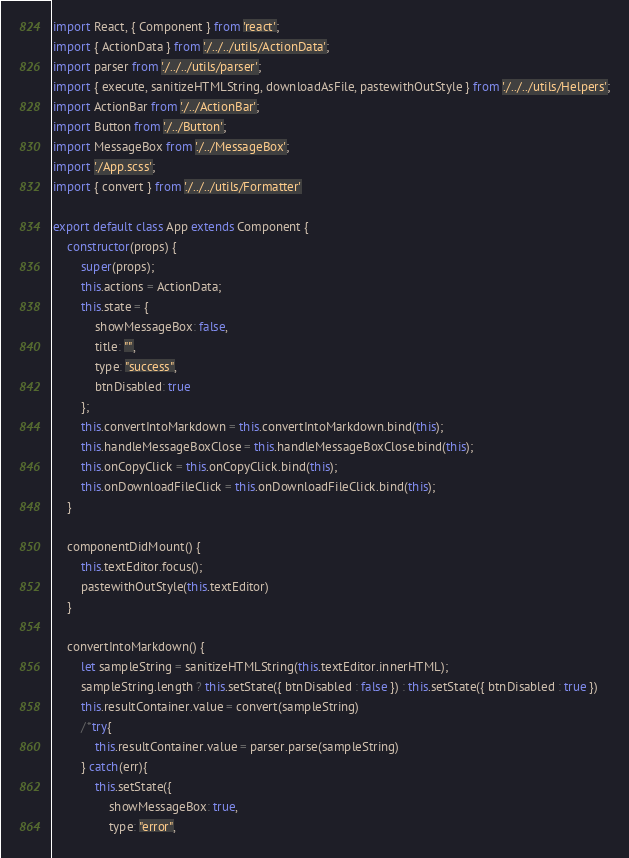<code> <loc_0><loc_0><loc_500><loc_500><_JavaScript_>import React, { Component } from 'react';
import { ActionData } from './../../utils/ActionData';
import parser from './../../utils/parser';
import { execute, sanitizeHTMLString, downloadAsFile, pastewithOutStyle } from './../../utils/Helpers';
import ActionBar from './../ActionBar';
import Button from './../Button';
import MessageBox from './../MessageBox';
import './App.scss';
import { convert } from './../../utils/Formatter'

export default class App extends Component {
    constructor(props) {
        super(props);
        this.actions = ActionData;
        this.state = {
            showMessageBox: false,
            title: "",
            type: "success",
            btnDisabled: true
        };
        this.convertIntoMarkdown = this.convertIntoMarkdown.bind(this);
        this.handleMessageBoxClose = this.handleMessageBoxClose.bind(this);
        this.onCopyClick = this.onCopyClick.bind(this);
        this.onDownloadFileClick = this.onDownloadFileClick.bind(this);
    }

    componentDidMount() {
        this.textEditor.focus();
        pastewithOutStyle(this.textEditor)
    }

    convertIntoMarkdown() {
        let sampleString = sanitizeHTMLString(this.textEditor.innerHTML);
        sampleString.length ? this.setState({ btnDisabled : false }) : this.setState({ btnDisabled : true })
        this.resultContainer.value = convert(sampleString)
        /*try{
            this.resultContainer.value = parser.parse(sampleString)
        } catch(err){   
            this.setState({
                showMessageBox: true,
                type: "error",</code> 